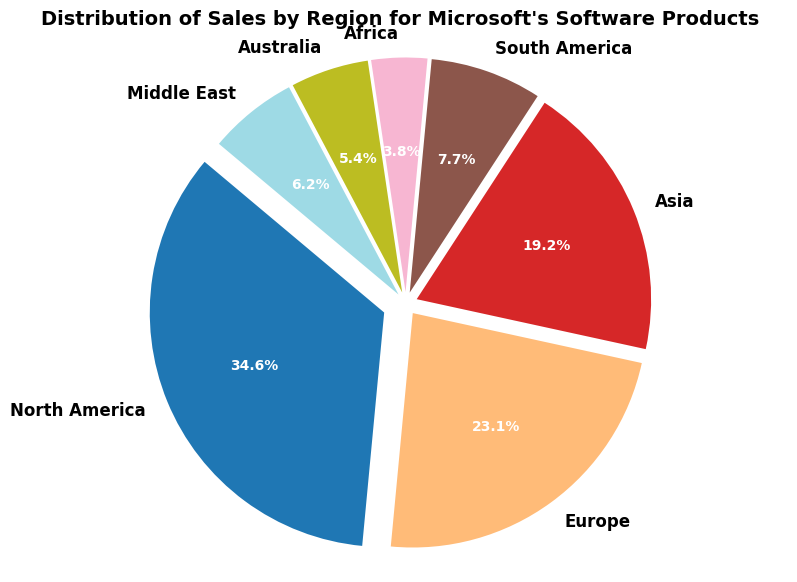What's the region with the highest sales? The region with the highest sales is the one with the largest slice in the pie chart. In our figure, North America has the largest slice.
Answer: North America What percentage of total sales comes from Asia and South America combined? To find this, add the percentage of sales from Asia and South America. The percentage for Asia is 20.0% and for South America is 8.0%. Adding these percentages together: 20.0% + 8.0% = 28.0%.
Answer: 28.0% Which region has approximately half the sales compared to North America? North America accounts for 45.0% of total sales. Looking for a region with approximately half, Europe has 30.0% which is closest to half (22.5%).
Answer: Europe Are Asia's sales greater than Australia and Africa combined? Asia accounts for 20.0% while Australia accounts for 7.0% and Africa accounts for 5.0%. Combined, Australia and Africa would be 7.0% + 5.0% = 12.0%. Since 20.0% is greater than 12.0%, Asia's sales are indeed greater.
Answer: Yes What is the difference in sales percentage between Europe and the Middle East? Europe contributes 30.0% to sales, while the Middle East contributes 8.0%. The difference is 30.0% - 8.0% = 22.0%.
Answer: 22.0% Which region is represented by a slice that's visually colored next to North America's slice? In our pie chart, regions are listed in order (starting at 12 o'clock and moving clockwise). The slice next to North America's highest slice (which is at the start) is Europe.
Answer: Europe How much more percentage does North America contribute compared to Africa? North America's contribution is 45.0%. Africa's contribution is 5.0%. The difference is 45.0% - 5.0% = 40.0%.
Answer: 40.0% Is the sum of sales from Africa, Australia, and the Middle East greater than that from Europe? Sum the percentages from Africa, Australia, and the Middle East: 5.0% + 7.0% + 8.0% = 20.0%. Europe contributes 30.0%. Since 20.0% is less than 30.0%, the sum is not greater than Europe's sales.
Answer: No Which region's sales make up more than 50% when combined with South America's sales? South America has 10.0%. Adding any region's percentage to it, North America's 45.0% reaches 55.0%, which is more than half. Other regions added do not exceed 50%.
Answer: North America 